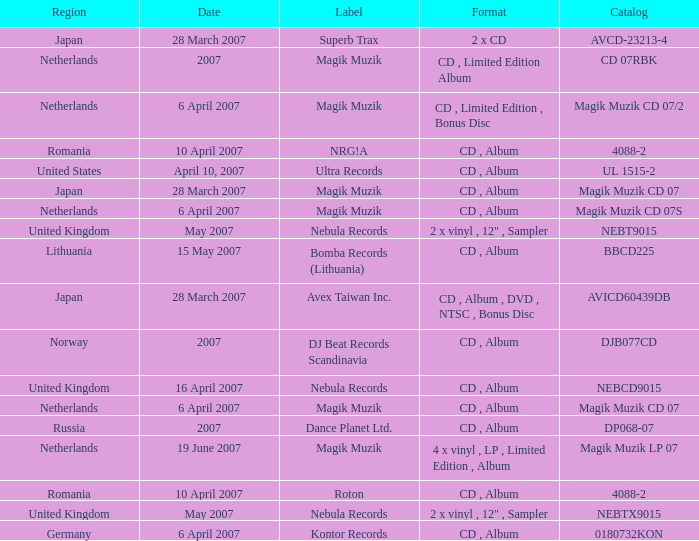From which region is the album with release date of 19 June 2007? Netherlands. Can you parse all the data within this table? {'header': ['Region', 'Date', 'Label', 'Format', 'Catalog'], 'rows': [['Japan', '28 March 2007', 'Superb Trax', '2 x CD', 'AVCD-23213-4'], ['Netherlands', '2007', 'Magik Muzik', 'CD , Limited Edition Album', 'CD 07RBK'], ['Netherlands', '6 April 2007', 'Magik Muzik', 'CD , Limited Edition , Bonus Disc', 'Magik Muzik CD 07/2'], ['Romania', '10 April 2007', 'NRG!A', 'CD , Album', '4088-2'], ['United States', 'April 10, 2007', 'Ultra Records', 'CD , Album', 'UL 1515-2'], ['Japan', '28 March 2007', 'Magik Muzik', 'CD , Album', 'Magik Muzik CD 07'], ['Netherlands', '6 April 2007', 'Magik Muzik', 'CD , Album', 'Magik Muzik CD 07S'], ['United Kingdom', 'May 2007', 'Nebula Records', '2 x vinyl , 12" , Sampler', 'NEBT9015'], ['Lithuania', '15 May 2007', 'Bomba Records (Lithuania)', 'CD , Album', 'BBCD225'], ['Japan', '28 March 2007', 'Avex Taiwan Inc.', 'CD , Album , DVD , NTSC , Bonus Disc', 'AVICD60439DB'], ['Norway', '2007', 'DJ Beat Records Scandinavia', 'CD , Album', 'DJB077CD'], ['United Kingdom', '16 April 2007', 'Nebula Records', 'CD , Album', 'NEBCD9015'], ['Netherlands', '6 April 2007', 'Magik Muzik', 'CD , Album', 'Magik Muzik CD 07'], ['Russia', '2007', 'Dance Planet Ltd.', 'CD , Album', 'DP068-07'], ['Netherlands', '19 June 2007', 'Magik Muzik', '4 x vinyl , LP , Limited Edition , Album', 'Magik Muzik LP 07'], ['Romania', '10 April 2007', 'Roton', 'CD , Album', '4088-2'], ['United Kingdom', 'May 2007', 'Nebula Records', '2 x vinyl , 12" , Sampler', 'NEBTX9015'], ['Germany', '6 April 2007', 'Kontor Records', 'CD , Album', '0180732KON']]} 